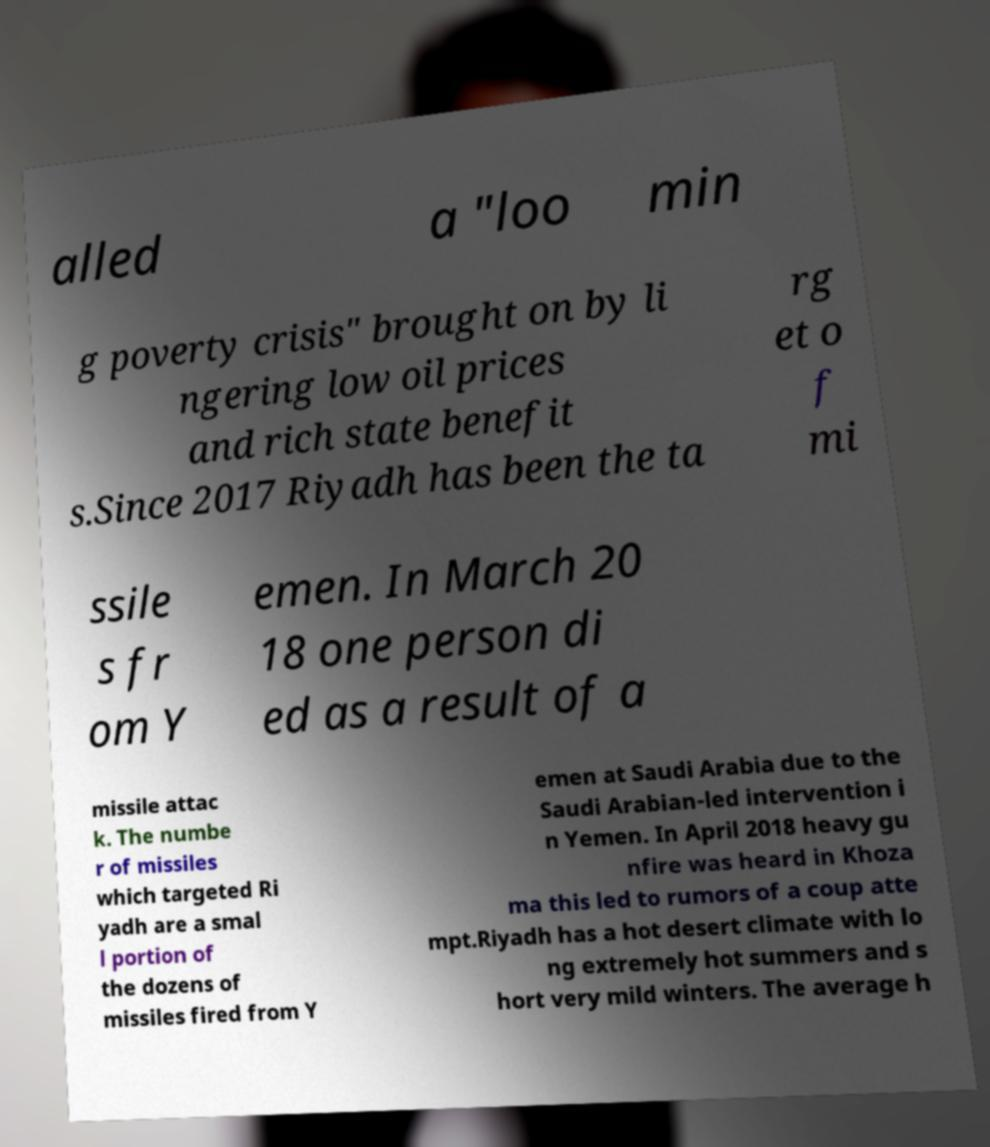I need the written content from this picture converted into text. Can you do that? alled a "loo min g poverty crisis" brought on by li ngering low oil prices and rich state benefit s.Since 2017 Riyadh has been the ta rg et o f mi ssile s fr om Y emen. In March 20 18 one person di ed as a result of a missile attac k. The numbe r of missiles which targeted Ri yadh are a smal l portion of the dozens of missiles fired from Y emen at Saudi Arabia due to the Saudi Arabian-led intervention i n Yemen. In April 2018 heavy gu nfire was heard in Khoza ma this led to rumors of a coup atte mpt.Riyadh has a hot desert climate with lo ng extremely hot summers and s hort very mild winters. The average h 